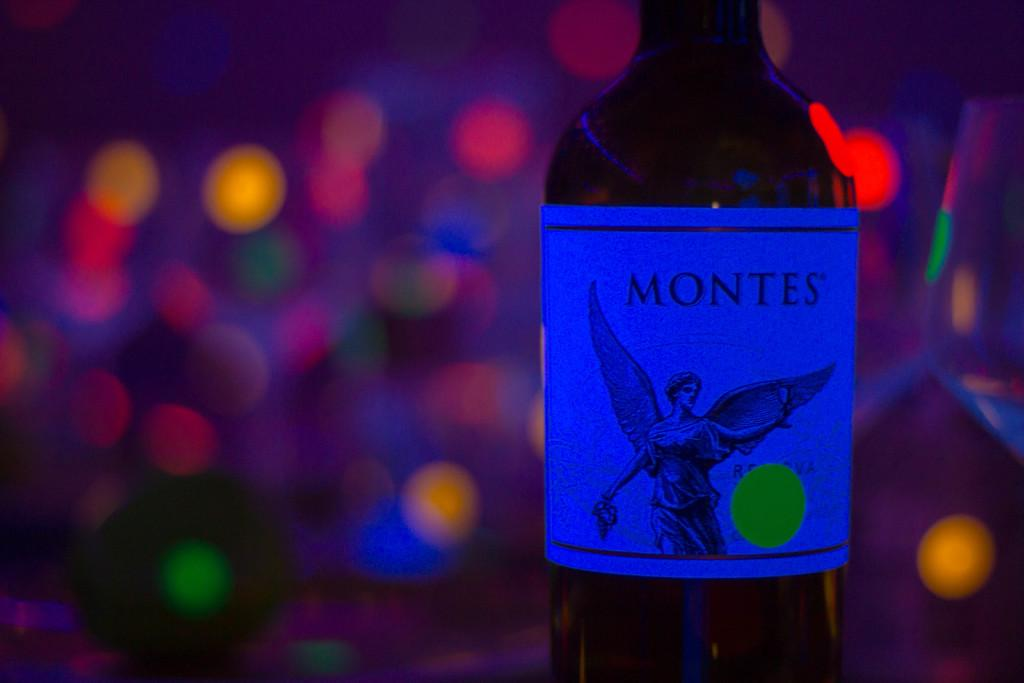<image>
Create a compact narrative representing the image presented. A bottle sits on the table that contains Montes. 